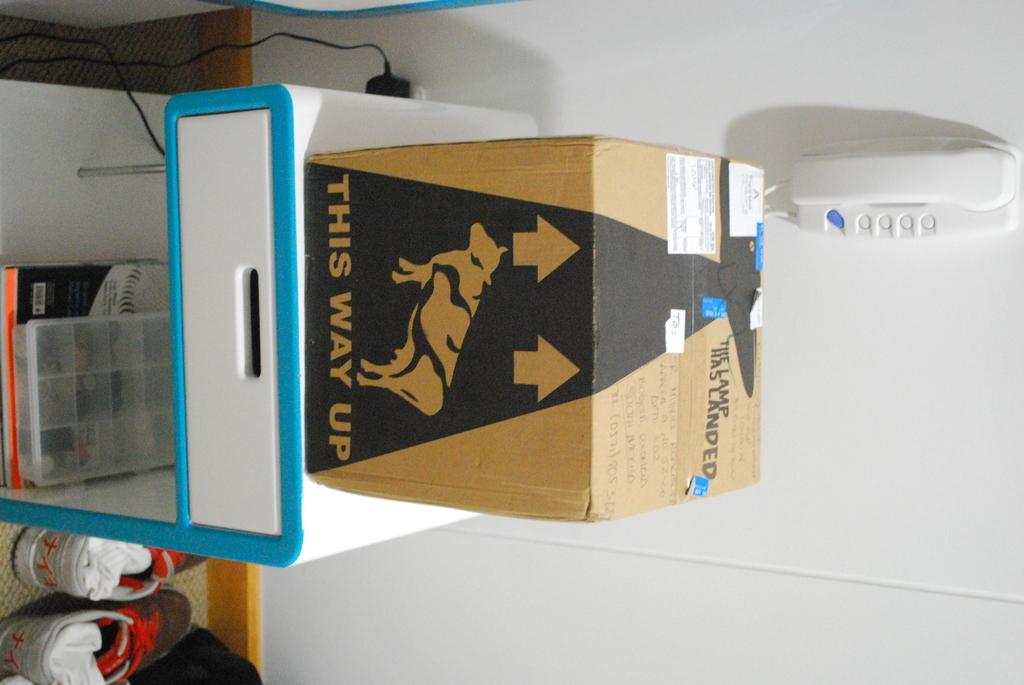This way is what?
Give a very brief answer. Up. What is in the box?
Give a very brief answer. Unanswerable. 